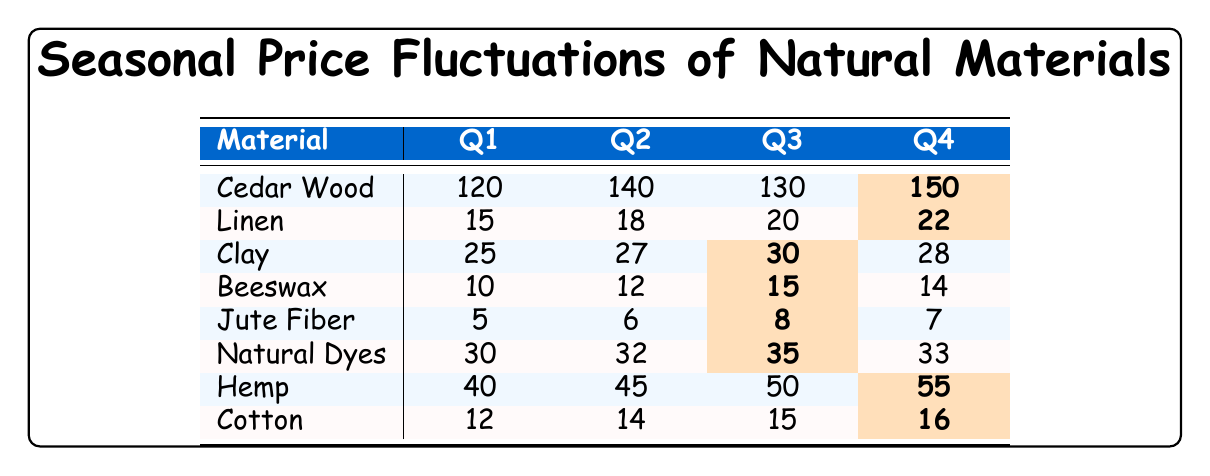What was the price of Cedar Wood in Q4? The table shows that the price of Cedar Wood in Q4 is highlighted, indicating it is the highest for that material, which is 150.
Answer: 150 Which natural material had the highest price in Q1? By examining the values in Q1, the highest price is for Cedar Wood, which is 120.
Answer: Cedar Wood What is the price difference of Linen from Q1 to Q4? The price of Linen in Q4 is 22 and in Q1 is 15. The difference is 22 - 15 = 7.
Answer: 7 Which material had the lowest price in Q2? Looking at the prices in Q2, Jute Fiber has the lowest price at 6.
Answer: Jute Fiber What is the average price of Hemp across all quarters? To find the average price of Hemp, add the prices for all quarters (40 + 45 + 50 + 55) = 190, and divide by 4, which gives 190/4 = 47.5.
Answer: 47.5 Was there any material that increased in price from Q3 to Q4? In the table, only Cedar Wood, Linen, and Hemp increase their prices from Q3 to Q4, indicating a yes response.
Answer: Yes What material had the most consistent price across the four quarters? To determine this, we examine the range of prices. Clay has prices of 25, 27, 30, and 28, which show the smallest fluctuation.
Answer: Clay What is the total price for all materials in Q3? Adding the prices of all materials for Q3 gives (130 + 20 + 30 + 15 + 8 + 35 + 50 + 15) = 308.
Answer: 308 Which two materials had the same price in Q1? The prices in Q1 are different for all materials, thus there are none with the same price.
Answer: No materials In which quarter did Natural Dyes have the highest price? Natural Dyes reached its highest price in Q3, with a value of 35 highlighted.
Answer: Q3 